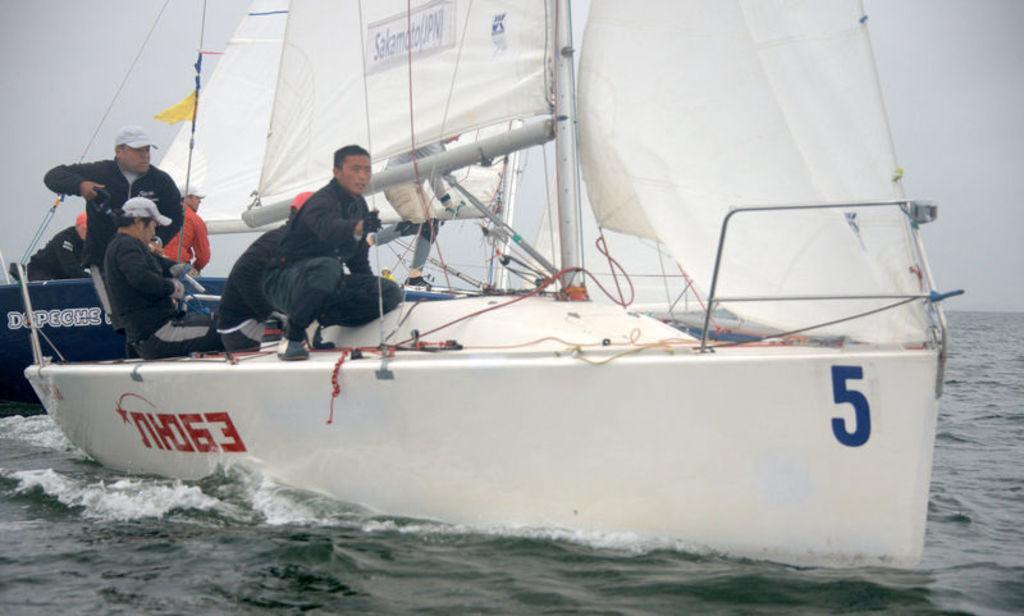Can you describe this image briefly? In this picture we can see boats and people and these boots are on water and we can see sky in the background. 